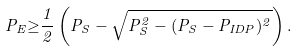<formula> <loc_0><loc_0><loc_500><loc_500>P _ { E } { \geq } \frac { 1 } { 2 } \left ( P _ { S } - \sqrt { P ^ { 2 } _ { S } - ( P _ { S } - P _ { I D P } ) ^ { 2 } } \right ) .</formula> 